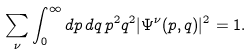Convert formula to latex. <formula><loc_0><loc_0><loc_500><loc_500>\sum _ { \nu } \int _ { 0 } ^ { \infty } d p \, d q \, p ^ { 2 } q ^ { 2 } | \Psi ^ { \nu } ( p , q ) | ^ { 2 } = 1 .</formula> 